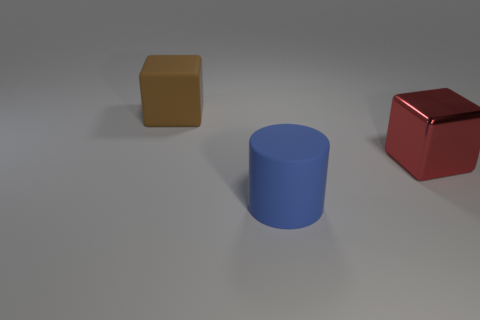Are there fewer red shiny blocks than small green metal things?
Provide a succinct answer. No. What number of green metallic things are the same shape as the large red object?
Make the answer very short. 0. How many purple things are matte blocks or large rubber cylinders?
Keep it short and to the point. 0. There is a matte object behind the rubber thing that is to the right of the brown rubber object; how big is it?
Your answer should be compact. Large. What material is the other large object that is the same shape as the big red shiny thing?
Offer a terse response. Rubber. What number of rubber cylinders have the same size as the red thing?
Your response must be concise. 1. Does the rubber cylinder have the same size as the red shiny thing?
Your answer should be compact. Yes. What is the size of the object that is both in front of the large brown block and on the left side of the large red block?
Keep it short and to the point. Large. Is the number of big things on the right side of the large brown rubber cube greater than the number of rubber cylinders in front of the large blue object?
Make the answer very short. Yes. There is another matte thing that is the same shape as the red thing; what color is it?
Keep it short and to the point. Brown. 